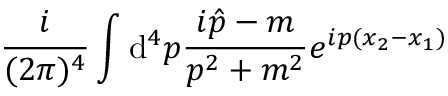<formula> <loc_0><loc_0><loc_500><loc_500>\frac { i } { ( 2 \pi ) ^ { 4 } } \int { \mathrm d } ^ { 4 } p \frac { i \hat { p } - m } { p ^ { 2 } + m ^ { 2 } } e ^ { i p ( x _ { 2 } - x _ { 1 } ) }</formula> 